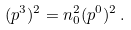<formula> <loc_0><loc_0><loc_500><loc_500>( p ^ { 3 } ) ^ { 2 } = n _ { 0 } ^ { 2 } ( p ^ { 0 } ) ^ { 2 } \, .</formula> 